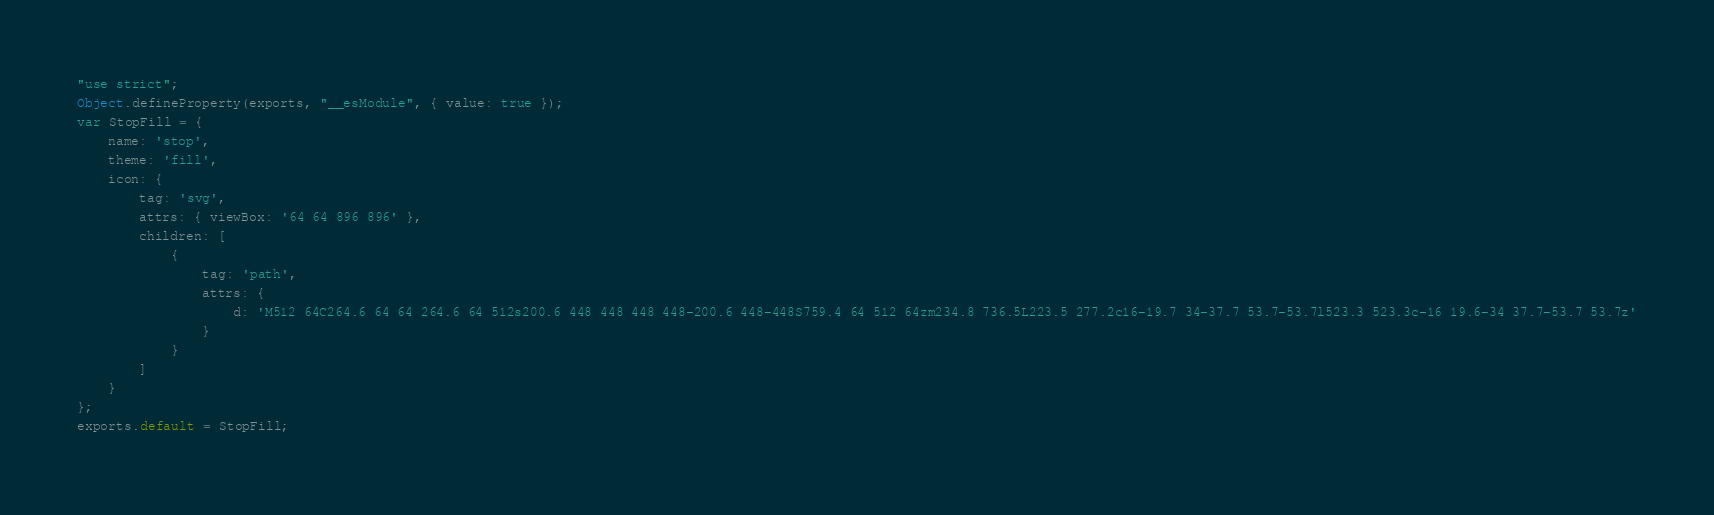Convert code to text. <code><loc_0><loc_0><loc_500><loc_500><_JavaScript_>"use strict";
Object.defineProperty(exports, "__esModule", { value: true });
var StopFill = {
    name: 'stop',
    theme: 'fill',
    icon: {
        tag: 'svg',
        attrs: { viewBox: '64 64 896 896' },
        children: [
            {
                tag: 'path',
                attrs: {
                    d: 'M512 64C264.6 64 64 264.6 64 512s200.6 448 448 448 448-200.6 448-448S759.4 64 512 64zm234.8 736.5L223.5 277.2c16-19.7 34-37.7 53.7-53.7l523.3 523.3c-16 19.6-34 37.7-53.7 53.7z'
                }
            }
        ]
    }
};
exports.default = StopFill;
</code> 